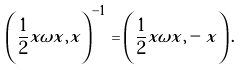Convert formula to latex. <formula><loc_0><loc_0><loc_500><loc_500>\left ( \frac { 1 } { 2 } x \omega x , x \right ) ^ { - 1 } = \left ( \frac { 1 } { 2 } x \omega x , - x \right ) .</formula> 